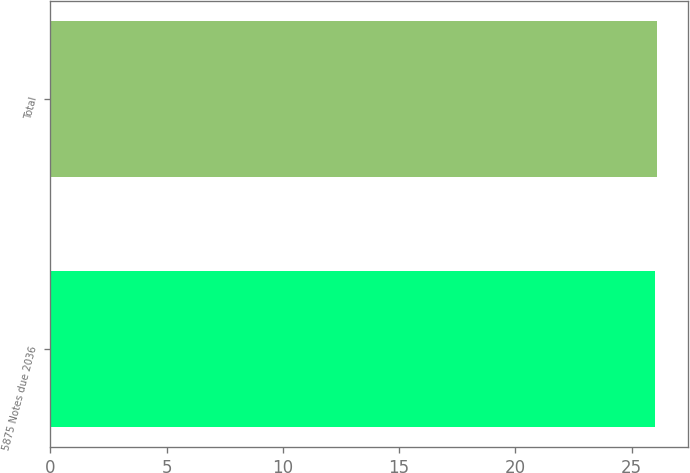Convert chart to OTSL. <chart><loc_0><loc_0><loc_500><loc_500><bar_chart><fcel>5875 Notes due 2036<fcel>Total<nl><fcel>26<fcel>26.1<nl></chart> 